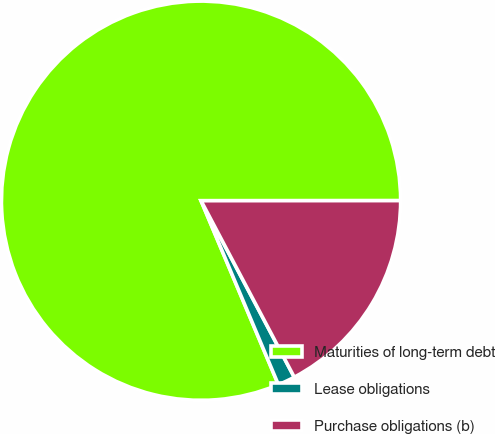<chart> <loc_0><loc_0><loc_500><loc_500><pie_chart><fcel>Maturities of long-term debt<fcel>Lease obligations<fcel>Purchase obligations (b)<nl><fcel>81.33%<fcel>1.4%<fcel>17.27%<nl></chart> 